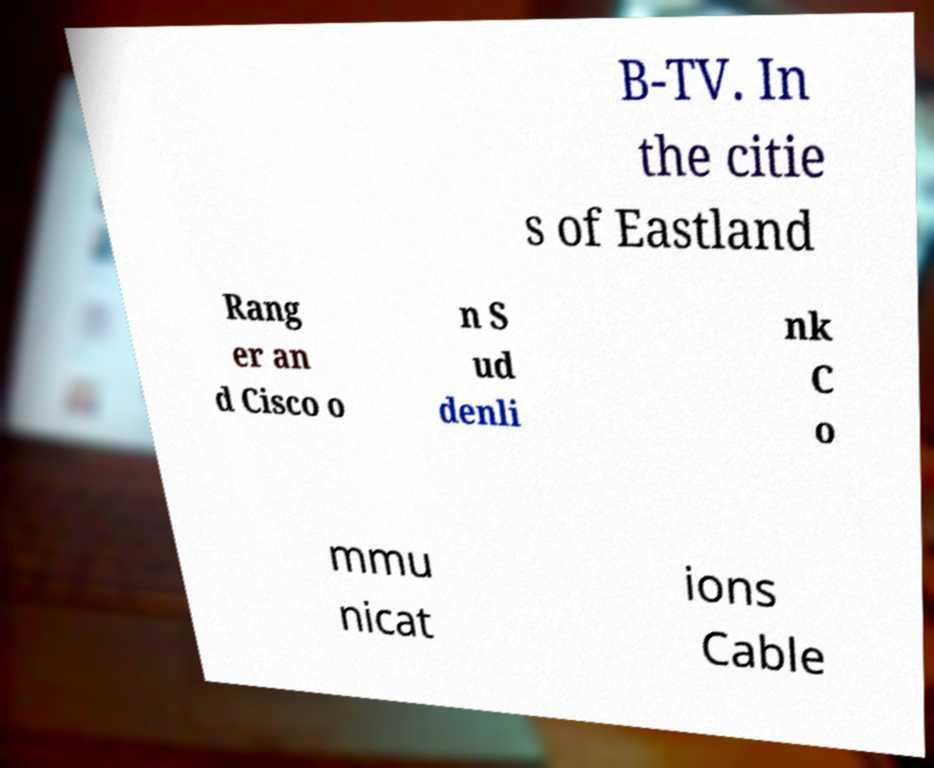There's text embedded in this image that I need extracted. Can you transcribe it verbatim? B-TV. In the citie s of Eastland Rang er an d Cisco o n S ud denli nk C o mmu nicat ions Cable 